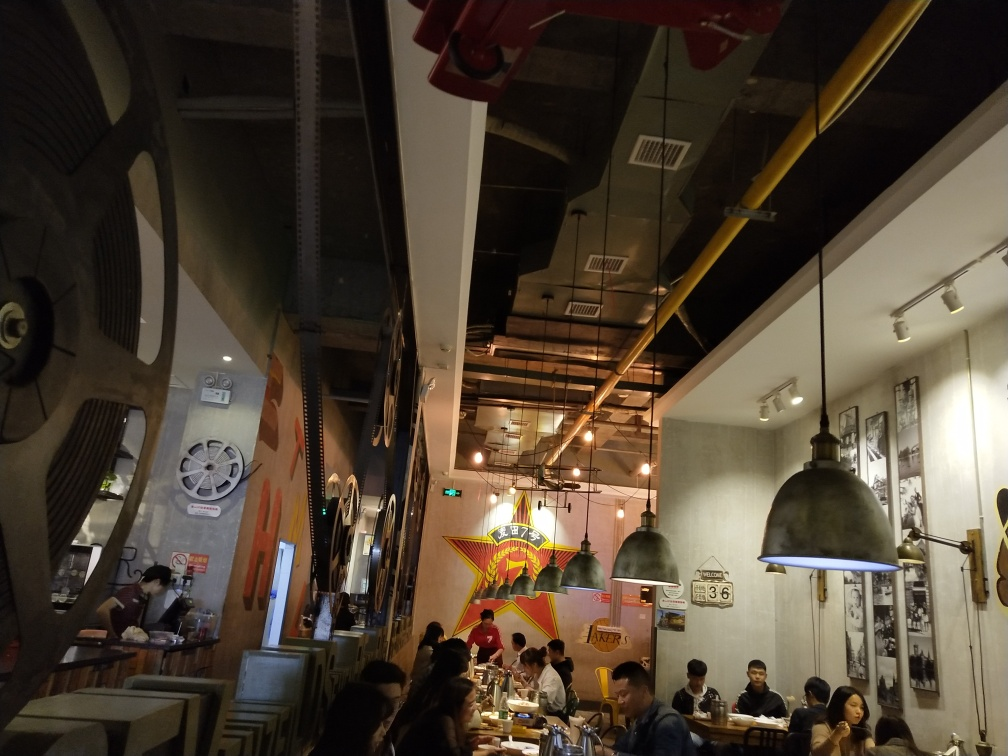Can you describe the atmosphere of the place shown in the image? The image depicts a lively indoor setting that appears to be a restaurant or cafe, featuring industrial-style decor with wall motifs, hanging lamps, and film-related decorations, suggesting a possible theme related to movies. The place seems to have a modern, casual ambience with patrons engaged in conversation, dining, and enjoying the setting. 